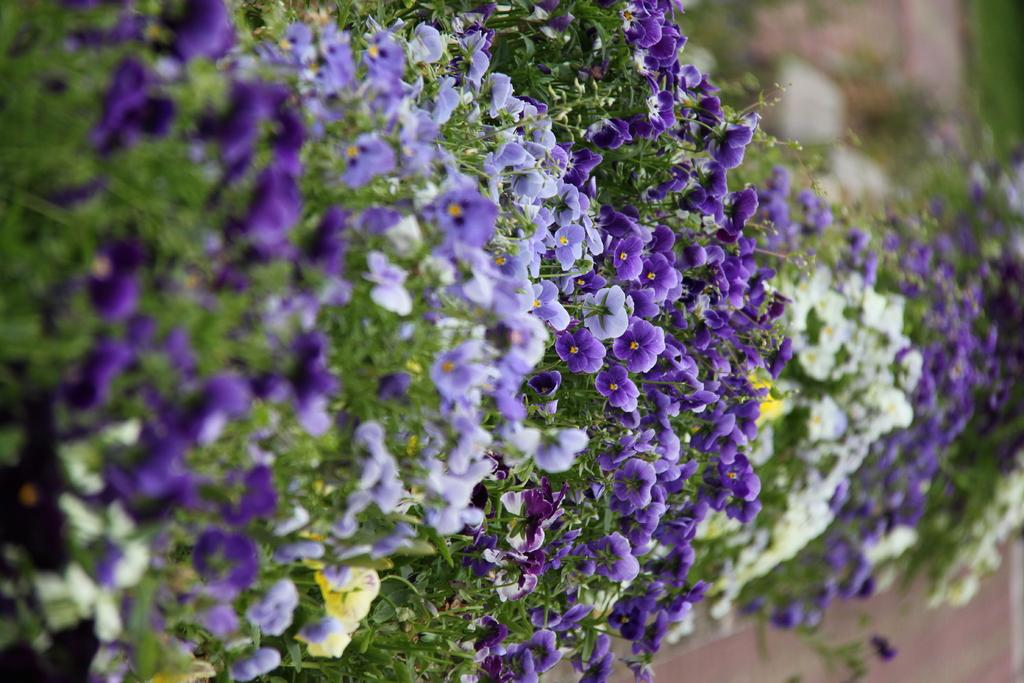What is the main subject of the image? The main subject of the image is a bunch of flowers. Can you describe the location of the flowers in the image? The flowers are near plants in the image. What type of ball can be seen rolling through the flowers in the image? There is no ball present in the image; it only features a bunch of flowers near plants. 